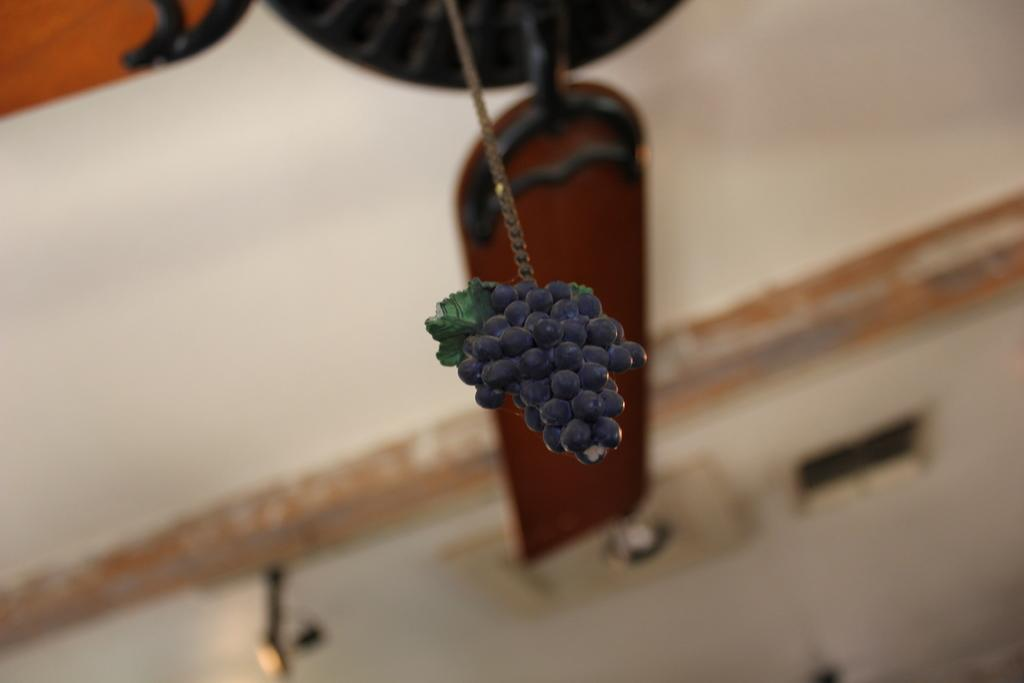What type of fruit is visible in the image? There are grapes in the image. What else can be seen behind the grapes? There are other objects behind the grapes. How would you describe the background of the image? The background of the image is blurred. What type of jam is being made with the grapes in the image? There is no jam-making process depicted in the image; it only shows grapes and other objects behind them. 